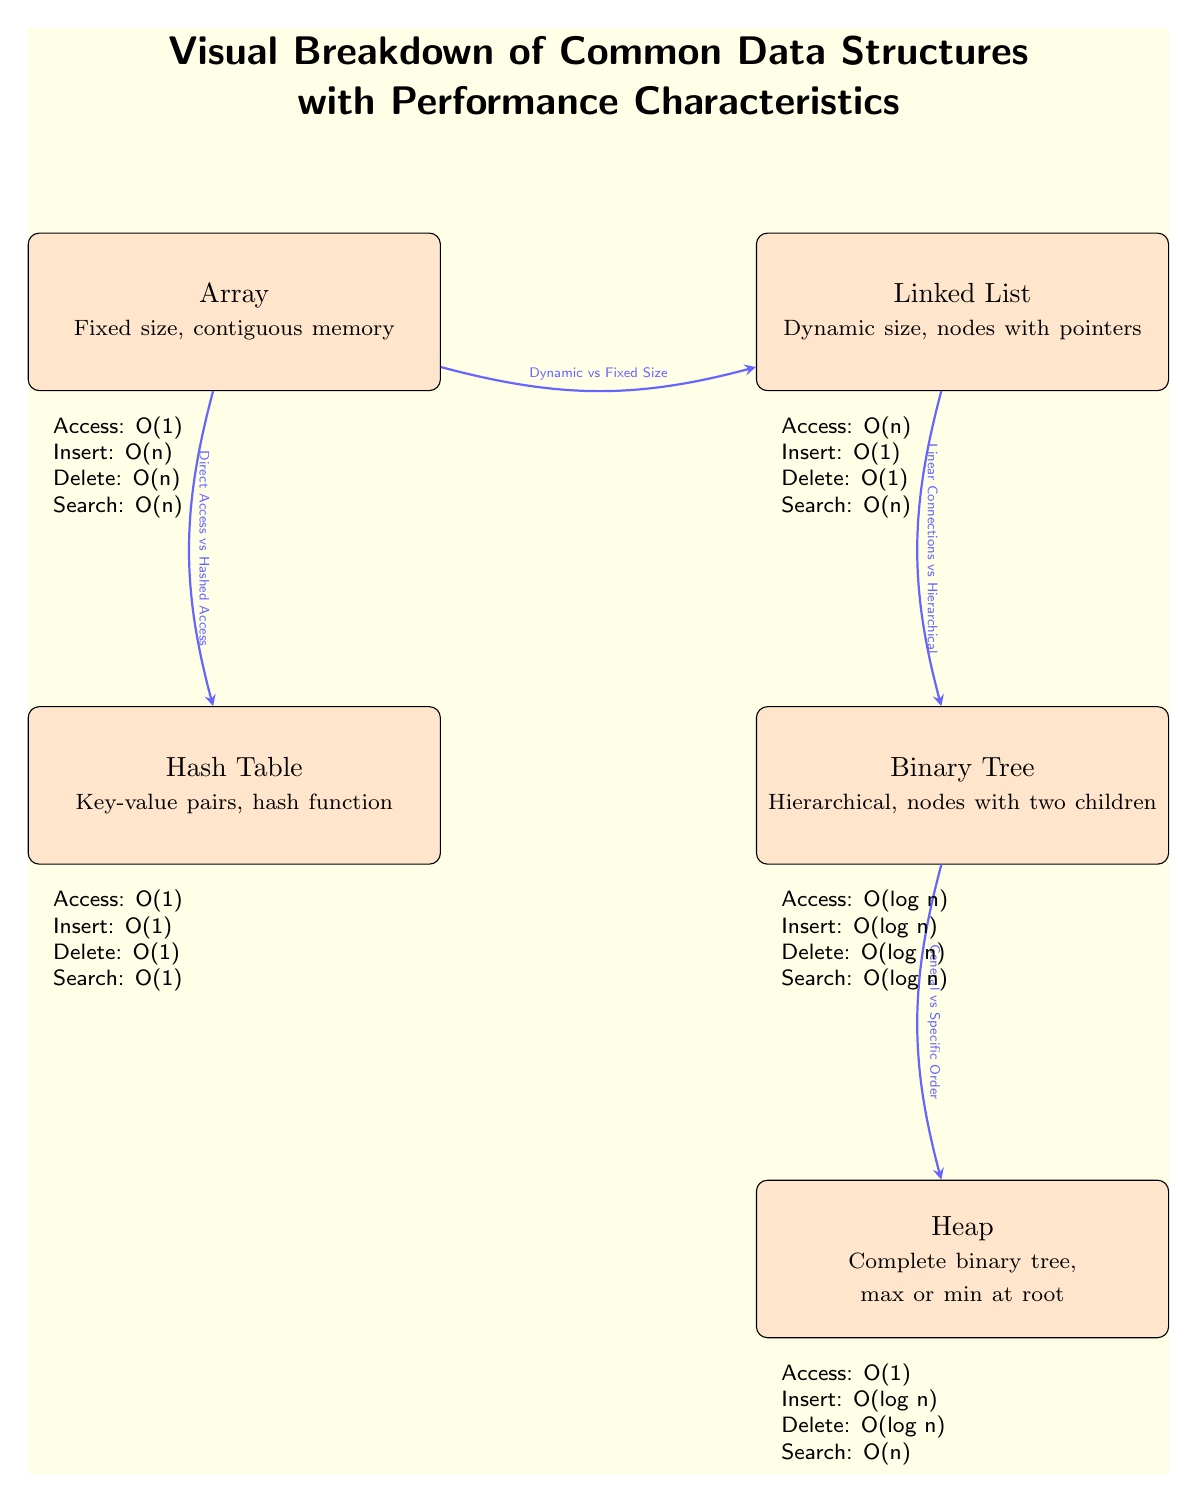What is the access time complexity for an Array? The diagram indicates that the access time complexity for an Array is O(1). This is found in the performance characteristics section for the Array node.
Answer: O(1) How many data structures are represented in the diagram? The diagram presents five data structures: Array, Linked List, Hash Table, Binary Tree, and Heap. This can be counted by recognizing each labeled node within the diagram.
Answer: 5 What type of memory allocation does a Linked List use? The diagram specifies that a Linked List has a dynamic size and is composed of nodes with pointers, indicating that it utilizes dynamic memory allocation. This is directly mentioned in the description of the Linked List node.
Answer: Dynamic size Which data structure exhibits a search time complexity of O(log n)? In the performance characteristics section, the Binary Tree node indicates a search time complexity of O(log n). This means that out of the listed data structures, the Binary Tree is the one that has this specific performance characteristic for search operations.
Answer: Binary Tree What is the relationship described between the Array and the Linked List? According to the edge connecting the Array and the Linked List, the relationship is described as "Dynamic vs Fixed Size." This indicates the contrast between the two structures regarding how their size can change over time.
Answer: Dynamic vs Fixed Size What is the insert time complexity for a Hash Table? The diagram states that the insert time complexity for a Hash Table is O(1), which is listed in the performance characteristics section for the Hash Table. This implies that inserting an item in a hash table can be done in constant time.
Answer: O(1) How many edges are present in the diagram? The diagram features four edges connecting the data structures, as indicated by the arrows that illustrate their relationships. Counting these edges yields a total of four.
Answer: 4 What access time complexity does a Heap have? The diagram shows that the access time complexity for a Heap is O(1). This detail is noted in the performance characteristics section associated with the Heap node.
Answer: O(1) What type of binary structure is described by a Binary Tree? The diagram describes a Binary Tree as hierarchical with nodes having two children. This description conveys the tree structure and its relationship between nodes.
Answer: Hierarchical 